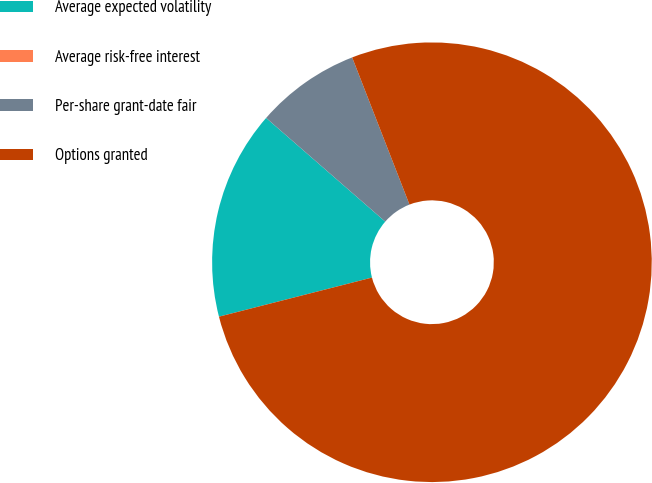Convert chart to OTSL. <chart><loc_0><loc_0><loc_500><loc_500><pie_chart><fcel>Average expected volatility<fcel>Average risk-free interest<fcel>Per-share grant-date fair<fcel>Options granted<nl><fcel>15.38%<fcel>0.0%<fcel>7.69%<fcel>76.92%<nl></chart> 